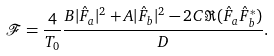<formula> <loc_0><loc_0><loc_500><loc_500>\mathcal { F } = \frac { 4 } { T _ { 0 } } \frac { B | \hat { F } _ { a } | ^ { 2 } + A | \hat { F } _ { b } | ^ { 2 } - 2 C \Re ( \hat { F } _ { a } \hat { F } _ { b } ^ { * } ) } { D } .</formula> 